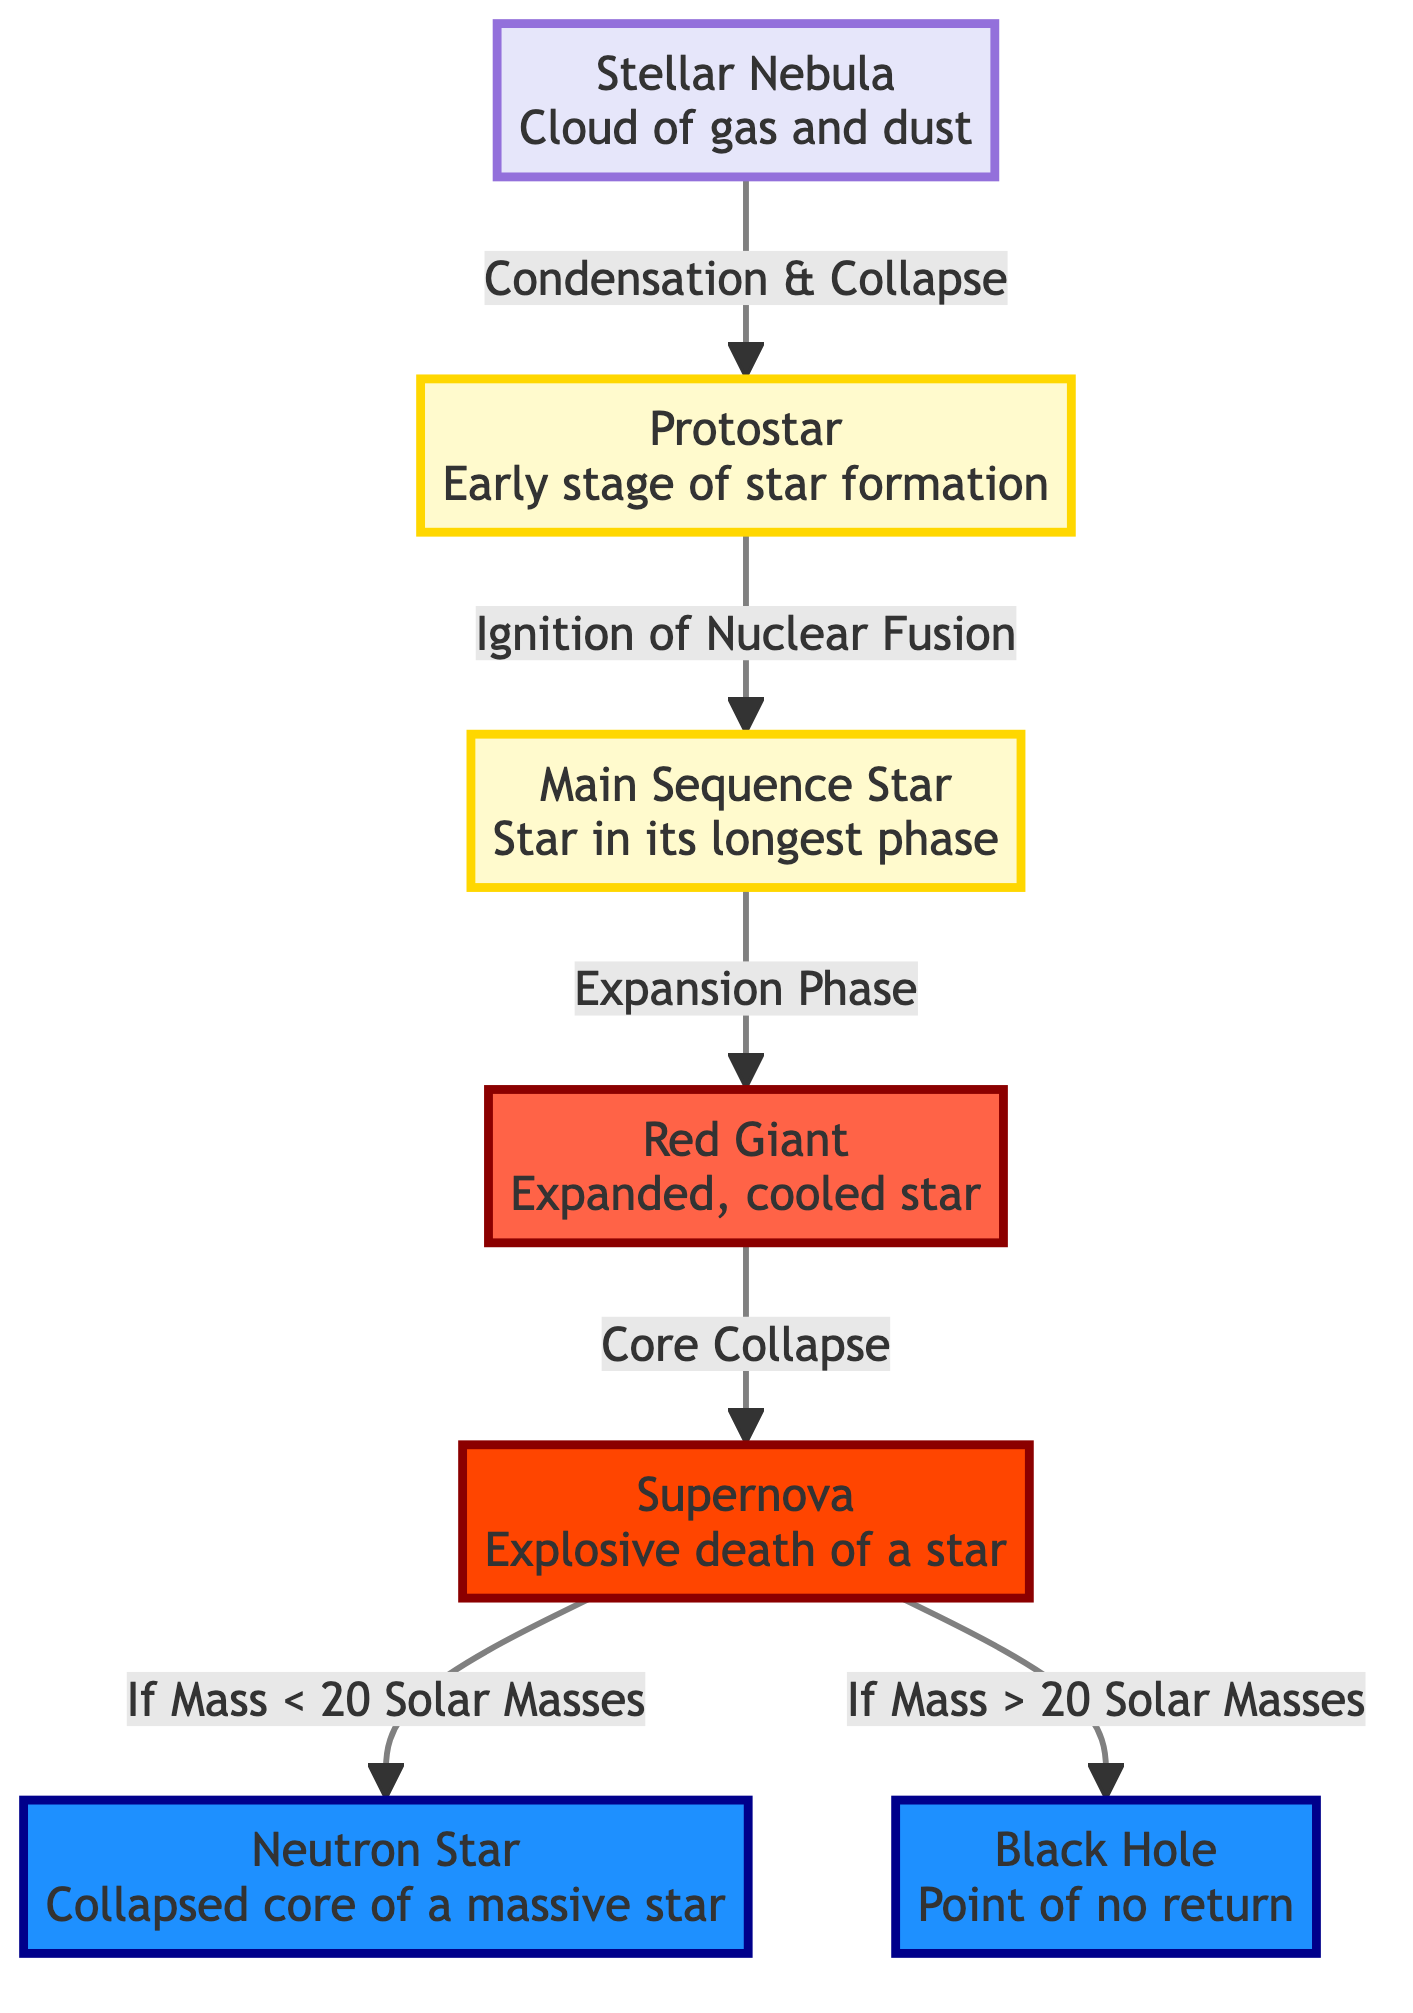What is the first stage of a star's lifecycle? The diagram shows that the first stage of a star's lifecycle is "Stellar Nebula," which is marked as the starting point of the flowchart.
Answer: Stellar Nebula How many stages are there from the Stellar Nebula to a Supernova? Counting the stages depicted in the flowchart, there are five distinct stages leading to a Supernova: Stellar Nebula, Protostar, Main Sequence Star, Red Giant, and Supernova.
Answer: 5 What happens after the Red Giant stage? According to the diagram, the Red Giant stage leads to the "Core Collapse" phase, which follows and results in a Supernova.
Answer: Supernova What stage leads to a Neutron Star? The diagram indicates that if the mass of the star is less than 20 solar masses after the Supernova, it evolves into a Neutron Star.
Answer: Neutron Star What condition leads to the formation of a Black Hole? The flowchart specifies that if the mass is greater than 20 solar masses after the Supernova, it results in the formation of a Black Hole.
Answer: If Mass > 20 Solar Masses What process transforms a Protostar into a Main Sequence Star? The transition from Protostar to Main Sequence Star is described in the diagram as "Ignition of Nuclear Fusion," indicating the critical process that occurs.
Answer: Ignition of Nuclear Fusion Which phase is the longest in a star's lifecycle? The diagram identifies the "Main Sequence Star" as the stage where a star spends the longest period of its lifecycle.
Answer: Main Sequence Star What is the final state of a star that has a mass less than 20 solar masses? The diagram shows that a star with less than 20 solar masses, after going through a Supernova, ends up as a Neutron Star.
Answer: Neutron Star 